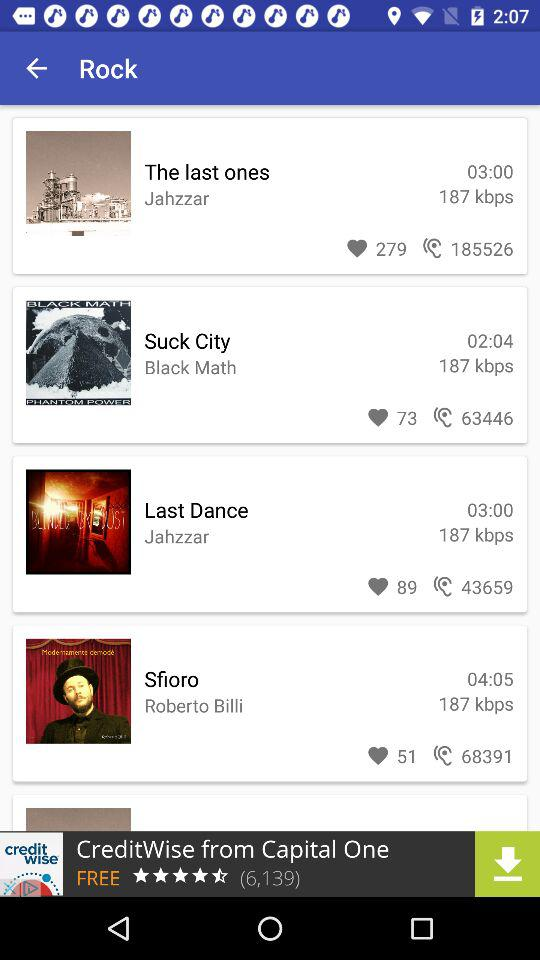How many have listened to "Last Dance"? There are 43659 people who have listened to "Last Dance". 